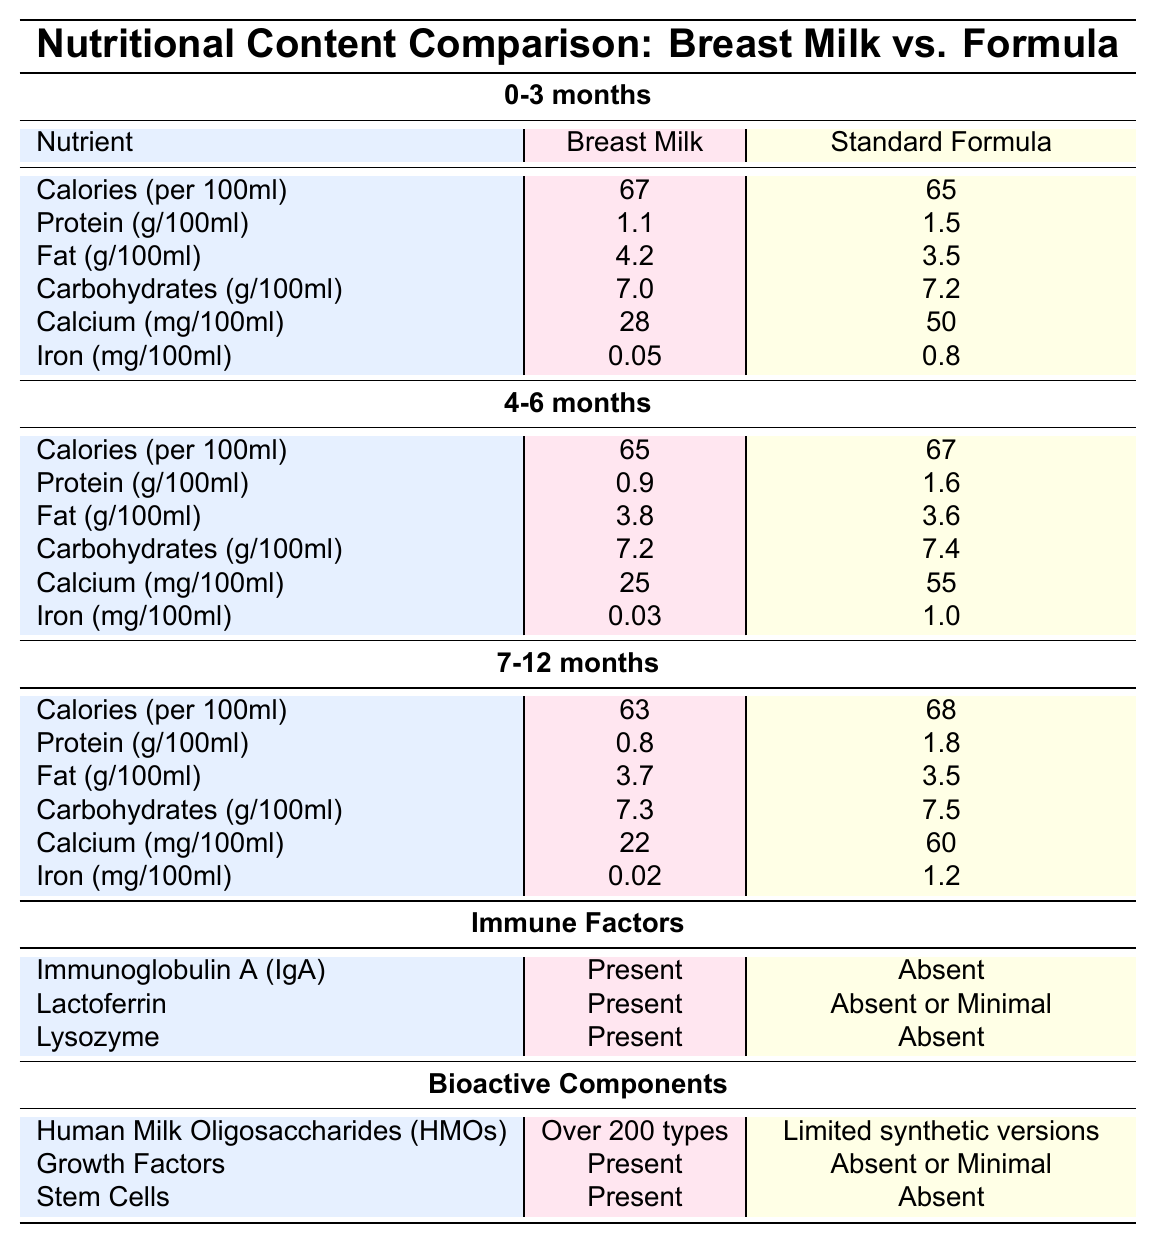What is the protein content in breast milk for the age group 0-3 months? From the table under the 0-3 months section, the protein content listed for breast milk is 1.1 g per 100ml.
Answer: 1.1 g How much calcium is found in standard formula for the 4-6 months age group? In the 4-6 months section of the table, the calcium content for standard formula is shown as 55 mg per 100ml.
Answer: 55 mg Which nutrient has the highest value in breast milk for infants aged 0-3 months? Looking at the 0-3 months section, the nutrient with the highest value in breast milk is fat, with a value of 4.2 g per 100ml.
Answer: Fat What is the difference in calories per 100ml between breast milk and standard formula for 7-12 months? For the 7-12 months age group, breast milk has 63 calories per 100ml and standard formula has 68 calories. The difference is calculated as 68 - 63 = 5.
Answer: 5 Is immunoglobulin A present in standard formula? According to the immune factors section in the table, immunoglobulin A (IgA) is present in breast milk but absent in standard formula.
Answer: No What is the average iron content in breast milk across all age groups? The iron content in breast milk for the three age groups is 0.05 mg (0-3 months), 0.03 mg (4-6 months), and 0.02 mg (7-12 months). The average is (0.05 + 0.03 + 0.02) / 3 = 0.0333 mg.
Answer: 0.0333 mg For the age group 4-6 months, which contains more carbohydrates, breast milk or standard formula? In the 4-6 months section, breast milk has 7.2 g of carbohydrates while standard formula has 7.4 g. Therefore, standard formula contains more carbohydrates.
Answer: Standard formula What is the total protein content in standard formula for age group 0-3 months compared to age group 7-12 months? For 0-3 months, the protein content in standard formula is 1.5 g, and for 7-12 months, it is 1.8 g. The total is 1.5 + 1.8 = 3.3 g.
Answer: 3.3 g Does breast milk contain more fat than standard formula for the 4-6 months age group? In the 4-6 months section, breast milk has 3.8 g of fat while standard formula has 3.6 g. Therefore, breast milk contains more fat.
Answer: Yes Calculate the difference in calcium content between breast milk and standard formula for the age group of 0-3 months. In the 0-3 months group, breast milk has 28 mg of calcium and standard formula has 50 mg. The difference is 50 - 28 = 22 mg.
Answer: 22 mg How many immune factors are present in breast milk but absent in standard formula? The table shows three immune factors: immunoglobulin A (IgA), lactoferrin, and lysozyme are present in breast milk and absent in standard formula. Thus, there are three immune factors.
Answer: 3 